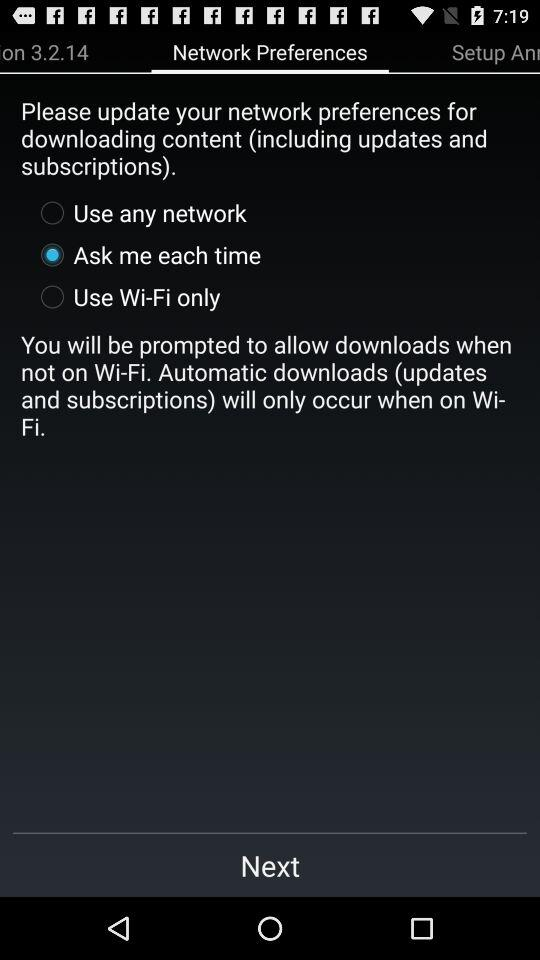Which option is selected for "Network Preferences"? The selected option is "Ask me each time". 